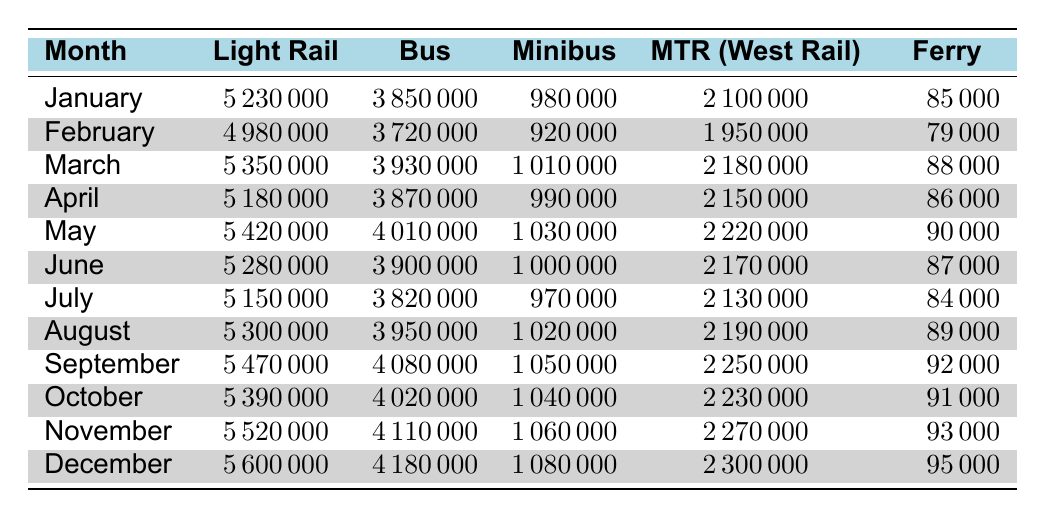What was the total ridership for Light Rail in December? In December, the Light Rail ridership was 5,600,000. This is obtained directly from the table.
Answer: 5,600,000 Which month saw the highest Minibus ridership? The highest Minibus ridership was in December at 1,080,000, as seen in the table data.
Answer: December What is the average ridership for the MTR (West Rail Line) over the year? To find the average, sum the MTR ridership for each month: (2,100,000 + 1,950,000 + 2,180,000 + 2,150,000 + 2,220,000 + 2,170,000 + 2,130,000 + 2,190,000 + 2,250,000 + 2,230,000 + 2,270,000 + 2,300,000) = 25,290,000, and divide by 12 months to get 2,107,500.
Answer: 2,107,500 Did the Light Rail ridership increase from January to December? Yes, the Light Rail ridership increased from 5,230,000 in January to 5,600,000 in December, indicating a positive trend over the year.
Answer: Yes What was the percentage increase in Bus ridership from February to July? The Bus ridership in February was 3,720,000 and in July it was 3,820,000. The increase is calculated as: (3,820,000 - 3,720,000) / 3,720,000 * 100 = 2.68%.
Answer: 2.68% Which transport mode consistently had the lowest ridership each month? The Ferry (Tuen Mun - Tung Chung) consistently had the lowest ridership every month as its numbers are notably lower than the other modes.
Answer: Ferry When was the total ridership of all transport modes highest? The highest total ridership occurred in December when the combined ridership was 5,600,000 + 4,180,000 + 1,080,000 + 2,300,000 + 95,000 = 13,255,000.
Answer: December What were the monthly Light Rail ridership numbers that exceeded 5,500,000? The months with Light Rail ridership exceeding 5,500,000 were November (5,520,000) and December (5,600,000) as seen in the table.
Answer: November, December Calculate the difference in ridership for the Bus between the month of the lowest and highest ridership. The lowest Bus ridership was in February (3,720,000) and the highest was in December (4,180,000). The difference is 4,180,000 - 3,720,000 = 460,000.
Answer: 460,000 What was the average Ferry ridership for the year? To find the average, sum the Ferry ridership for each month: (85,000 + 79,000 + 88,000 + 86,000 + 90,000 + 87,000 + 84,000 + 89,000 + 92,000 + 91,000 + 93,000 + 95,000) = 1,052,000 and divide by 12 months to get 87,666.67, rounded to 87,667.
Answer: 87,667 What was the trend in MTR (West Rail Line) ridership from January to December? The MTR ridership showed a gradual increase from 2,100,000 in January to 2,300,000 in December, indicating a consistent upward trend over the months.
Answer: Increasing 